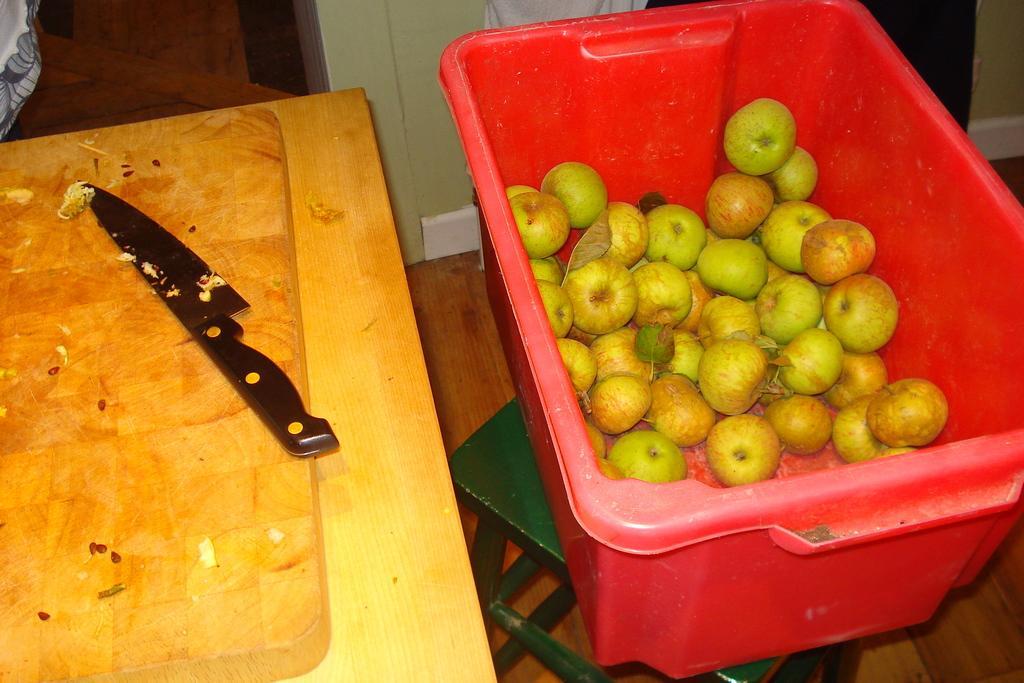Describe this image in one or two sentences. In this image, we can see some apples in a red colored container placed on a stool. We can see a knife on the wooden surface. We can see the ground. 